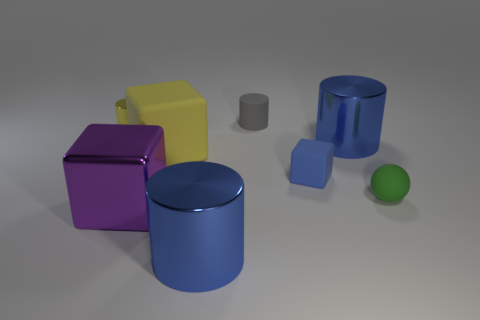Add 1 metallic blocks. How many objects exist? 9 Subtract all spheres. How many objects are left? 7 Subtract 0 cyan cubes. How many objects are left? 8 Subtract all large blue metallic cylinders. Subtract all cylinders. How many objects are left? 2 Add 1 cubes. How many cubes are left? 4 Add 6 cubes. How many cubes exist? 9 